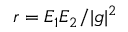Convert formula to latex. <formula><loc_0><loc_0><loc_500><loc_500>r = E _ { 1 } E _ { 2 } / | g | ^ { 2 }</formula> 